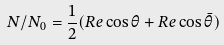Convert formula to latex. <formula><loc_0><loc_0><loc_500><loc_500>N / N _ { 0 } = \frac { 1 } { 2 } ( R e \cos \theta + R e \cos \bar { \theta } )</formula> 